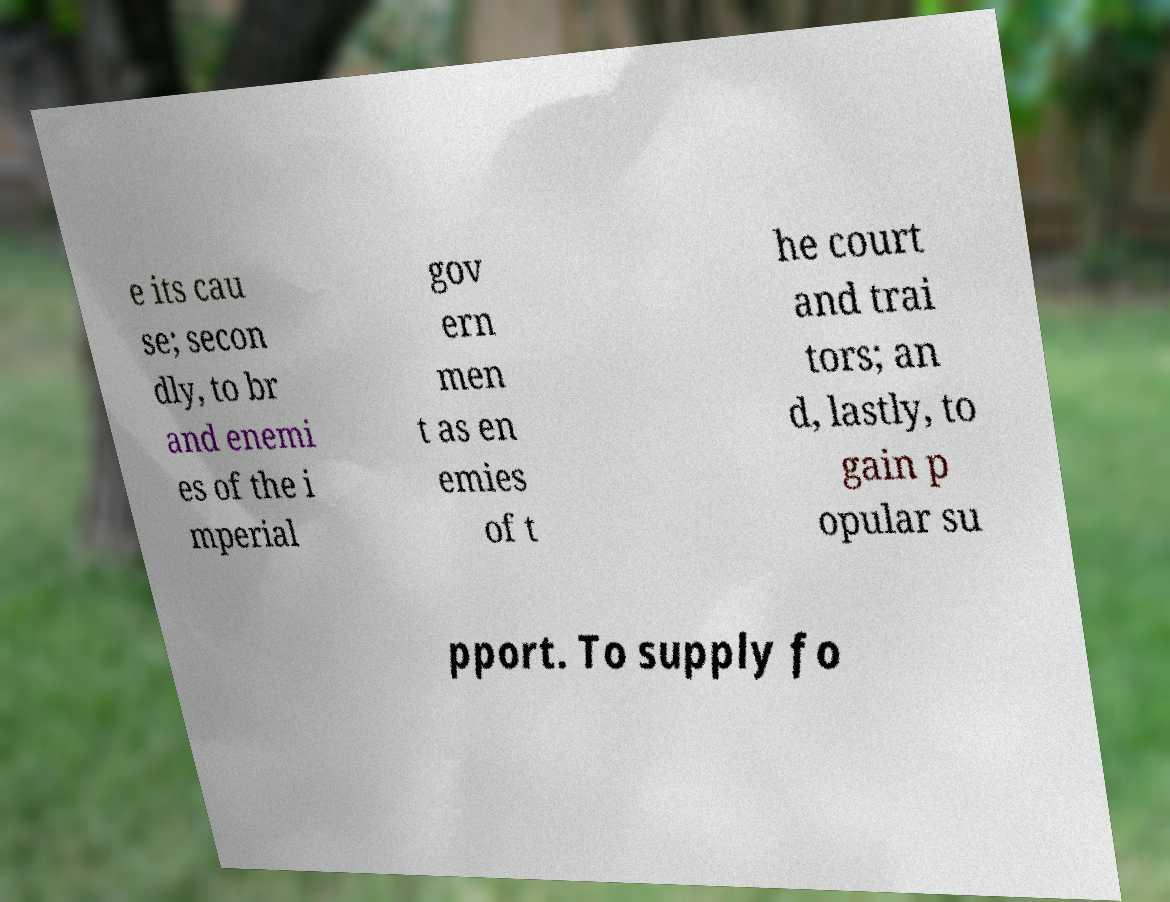There's text embedded in this image that I need extracted. Can you transcribe it verbatim? e its cau se; secon dly, to br and enemi es of the i mperial gov ern men t as en emies of t he court and trai tors; an d, lastly, to gain p opular su pport. To supply fo 